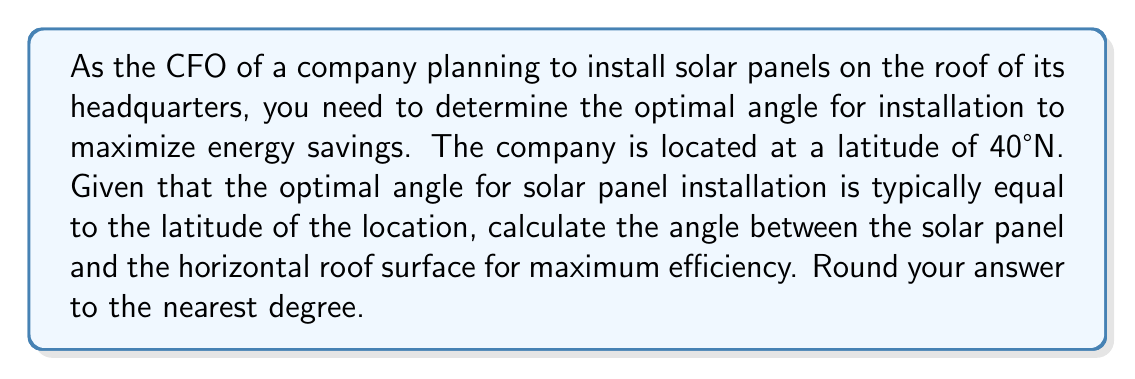Give your solution to this math problem. To solve this problem, we need to understand the relationship between the optimal angle for solar panel installation and the latitude of the location. Let's break it down step-by-step:

1. The general rule for optimal solar panel angle:
   The optimal angle for fixed solar panels is typically equal to the latitude of the location.

2. Given information:
   - The company is located at a latitude of 40°N

3. Calculating the optimal angle:
   Since the optimal angle is equal to the latitude, the angle between the solar panel and the horizontal roof surface should be 40°.

4. Visualization:
   [asy]
   import geometry;
   
   size(200);
   
   pair A = (0,0), B = (100,0), C = (100,84);
   draw(A--B--C--A);
   
   label("Roof", (50,-10), S);
   label("Solar Panel", (120,42), E);
   label("40°", (105,20), E);
   
   draw(arc(B,20,0,40), Arrow);
   [/asy]

5. Rounding:
   The angle is already a whole number, so no rounding is necessary.

This angle will allow the solar panels to capture the maximum amount of solar energy throughout the year, optimizing the company's energy savings.
Answer: 40° 